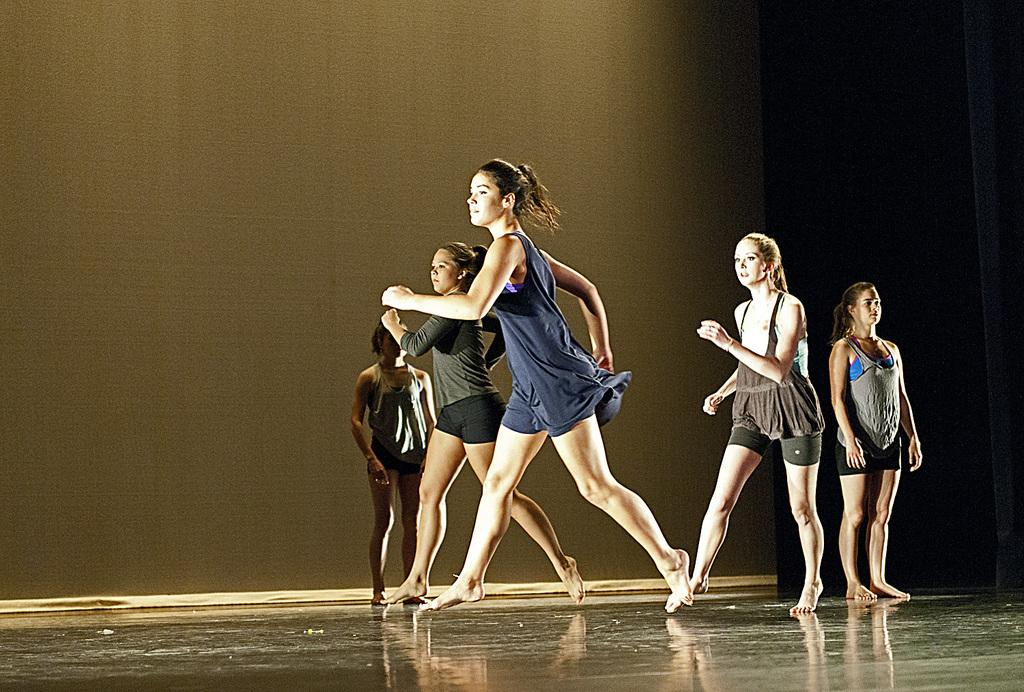What are the people in the image doing? The people in the image are dancing. How are the people positioned in relation to the floor? Some people are standing on the floor. What can be seen in the background of the image? There is a curtain in the background of the image. What type of answer can be seen being written on the boy's paper in the office? There is no boy or paper present in the image, and the image does not depict an office setting. 